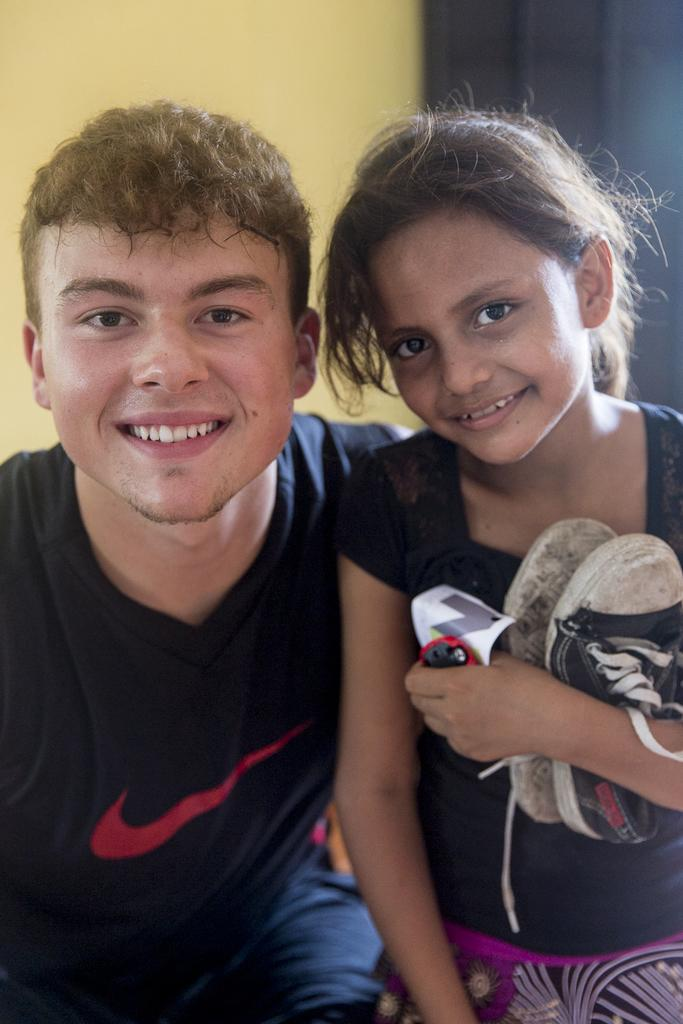What can be seen on the left side of the image? There is a boy on the left side of the image. What can be seen on the right side of the image? There is a girl on the right side of the image. What is the girl holding in her hands? The girl is holding shoes and a sticker. What is visible in the background of the image? There is a wall in the background of the image. How many times does the base burst in the image? There is no base or bursting action present in the image. 